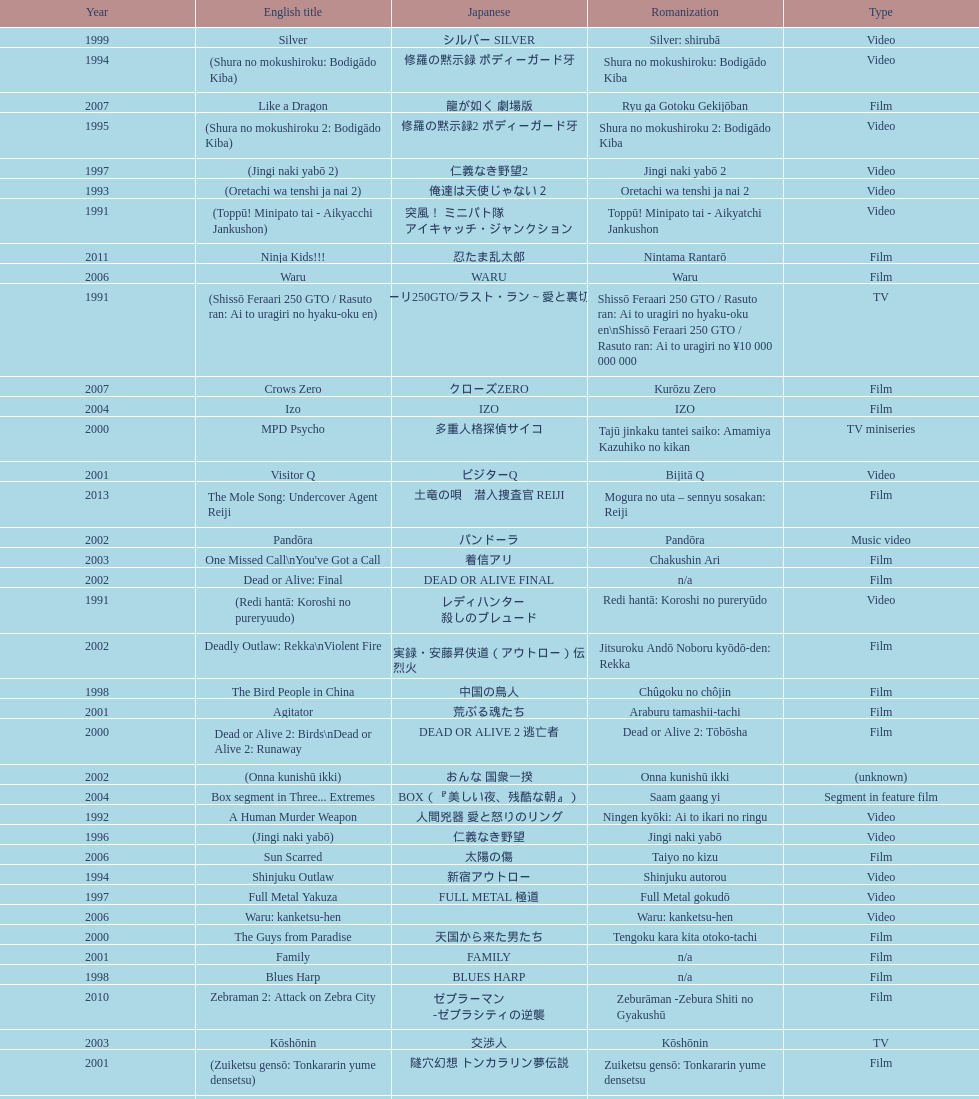Name a film that was released before 1996. Shinjuku Triad Society. 